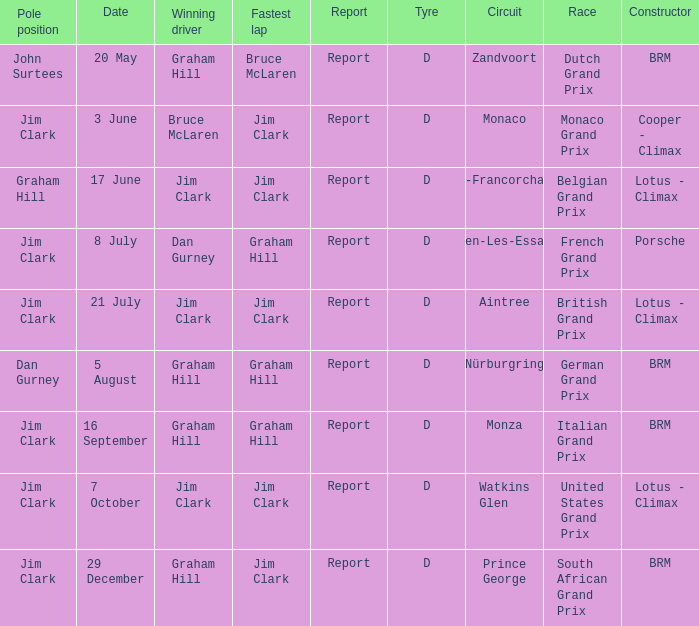What is the date of the circuit of Monaco? 3 June. 